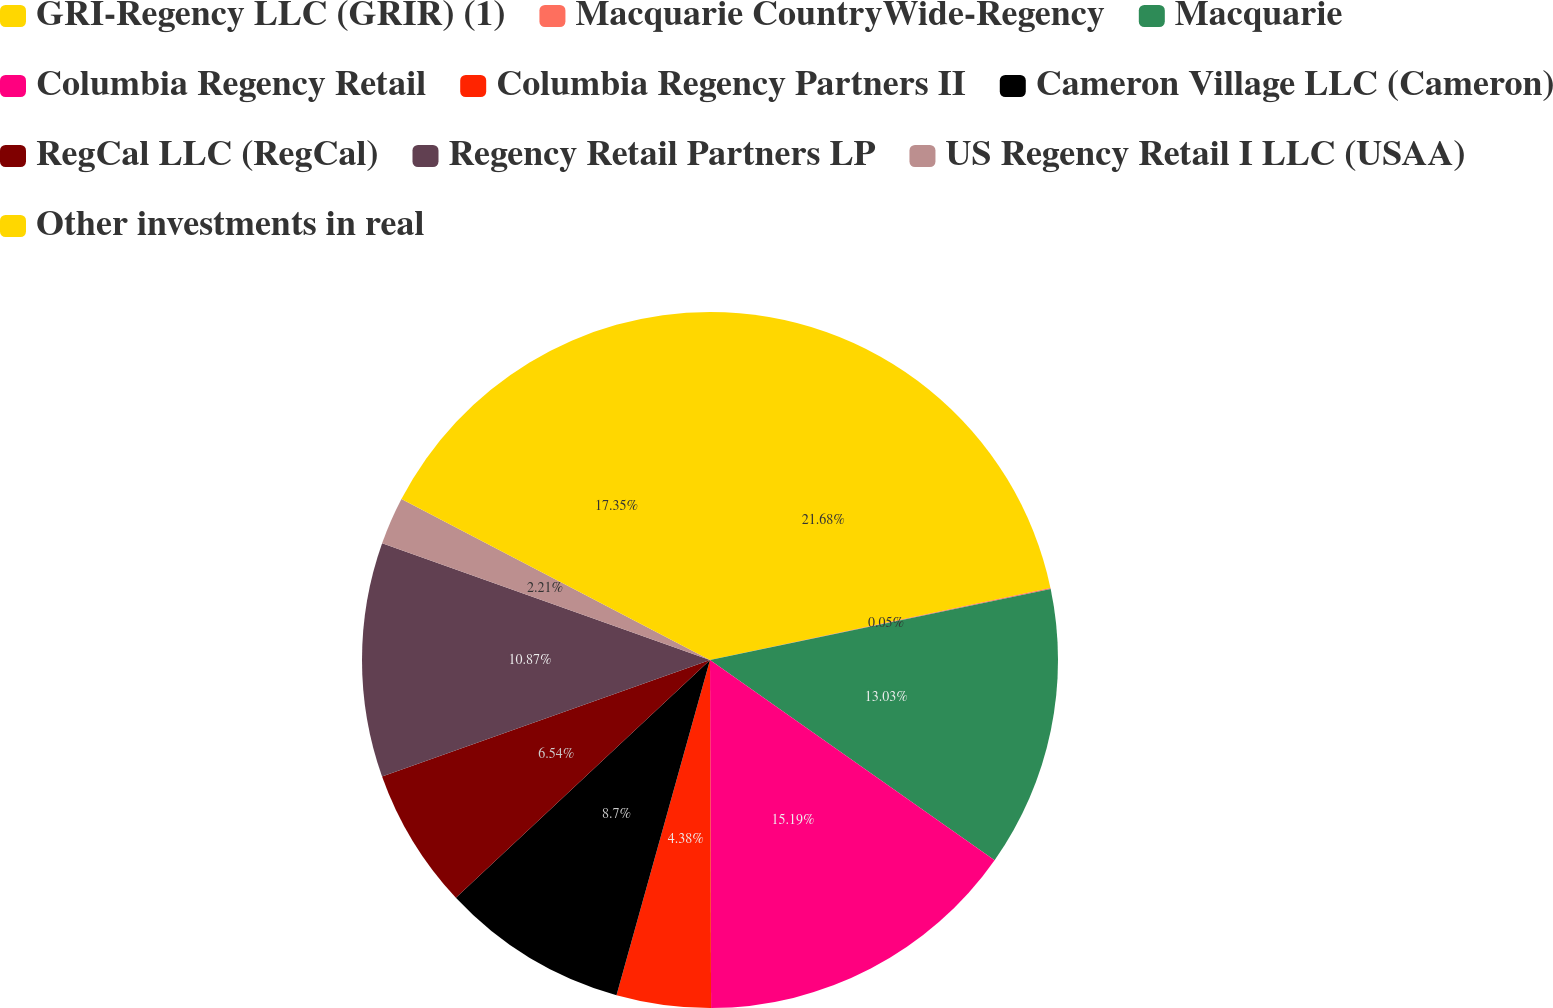<chart> <loc_0><loc_0><loc_500><loc_500><pie_chart><fcel>GRI-Regency LLC (GRIR) (1)<fcel>Macquarie CountryWide-Regency<fcel>Macquarie<fcel>Columbia Regency Retail<fcel>Columbia Regency Partners II<fcel>Cameron Village LLC (Cameron)<fcel>RegCal LLC (RegCal)<fcel>Regency Retail Partners LP<fcel>US Regency Retail I LLC (USAA)<fcel>Other investments in real<nl><fcel>21.68%<fcel>0.05%<fcel>13.03%<fcel>15.19%<fcel>4.38%<fcel>8.7%<fcel>6.54%<fcel>10.87%<fcel>2.21%<fcel>17.35%<nl></chart> 